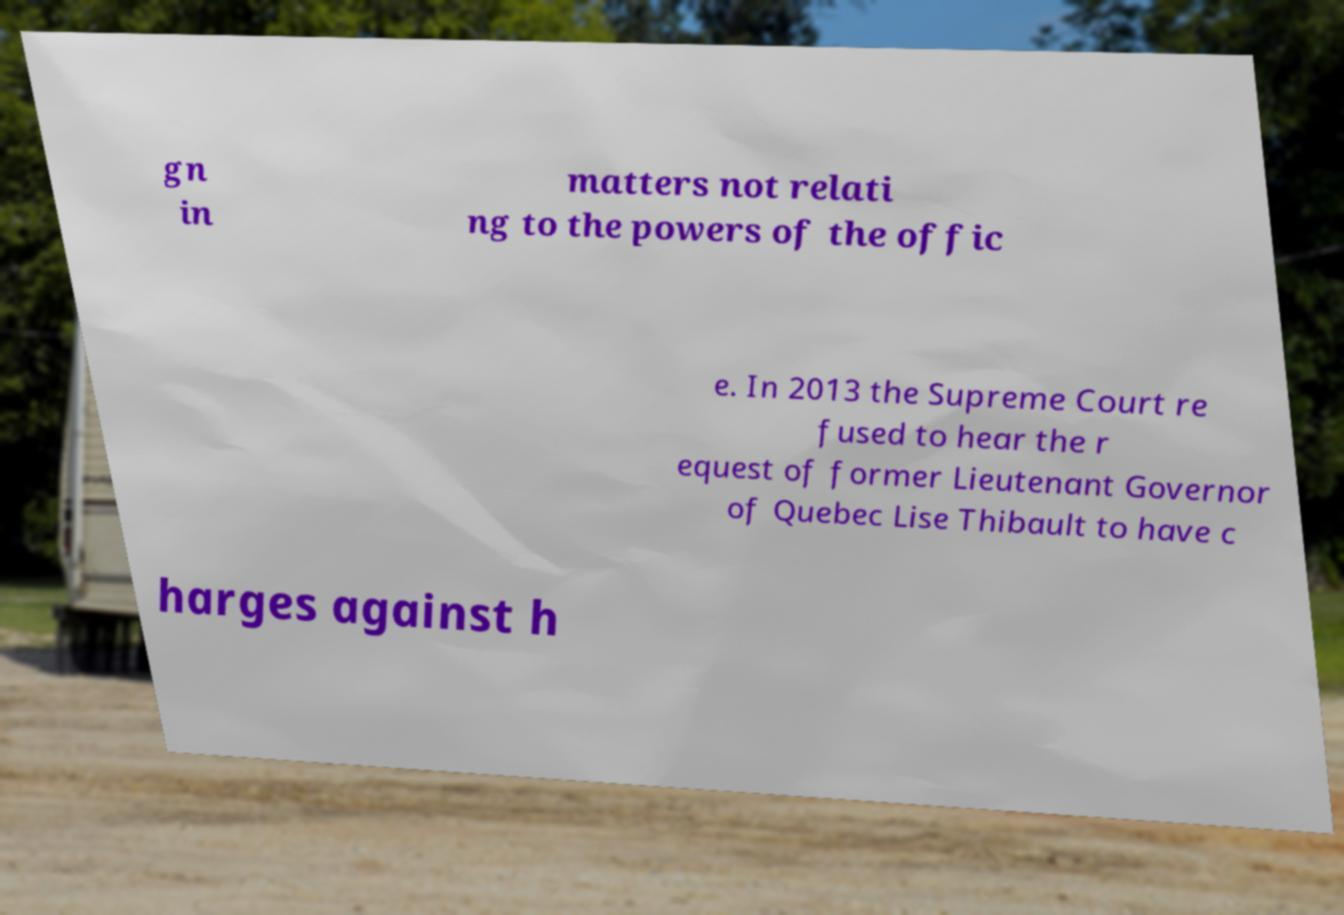There's text embedded in this image that I need extracted. Can you transcribe it verbatim? gn in matters not relati ng to the powers of the offic e. In 2013 the Supreme Court re fused to hear the r equest of former Lieutenant Governor of Quebec Lise Thibault to have c harges against h 